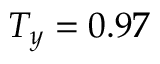<formula> <loc_0><loc_0><loc_500><loc_500>T _ { y } = 0 . 9 7</formula> 